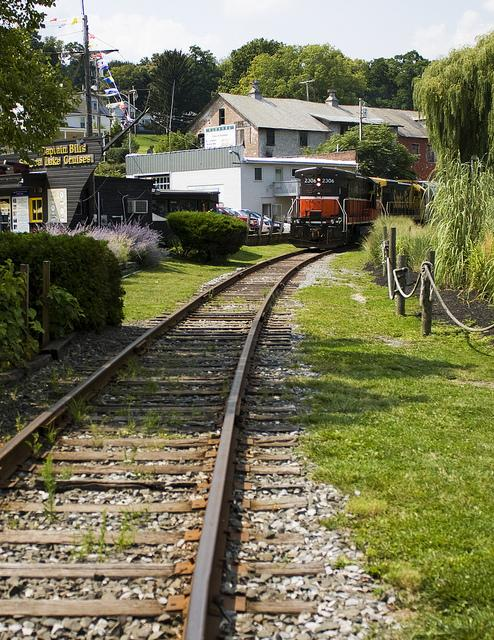What color is the lateral stripe around the train engine? white 